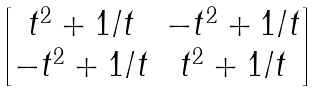Convert formula to latex. <formula><loc_0><loc_0><loc_500><loc_500>\begin{bmatrix} t ^ { 2 } + 1 / t & - t ^ { 2 } + 1 / t \\ - t ^ { 2 } + 1 / t & t ^ { 2 } + 1 / t \end{bmatrix}</formula> 